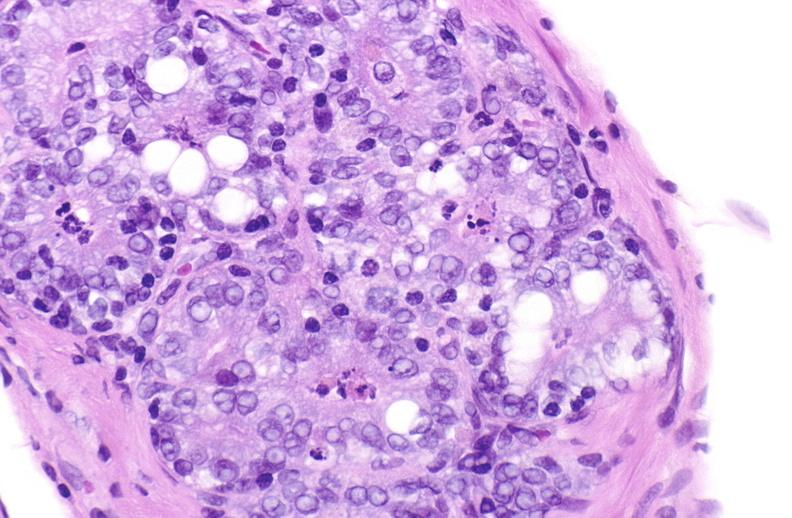when does this image show apoptosis in prostate?
Answer the question using a single word or phrase. After orchiectomy 